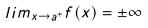<formula> <loc_0><loc_0><loc_500><loc_500>l i m _ { x \rightarrow a ^ { + } } f ( x ) = \pm \infty</formula> 